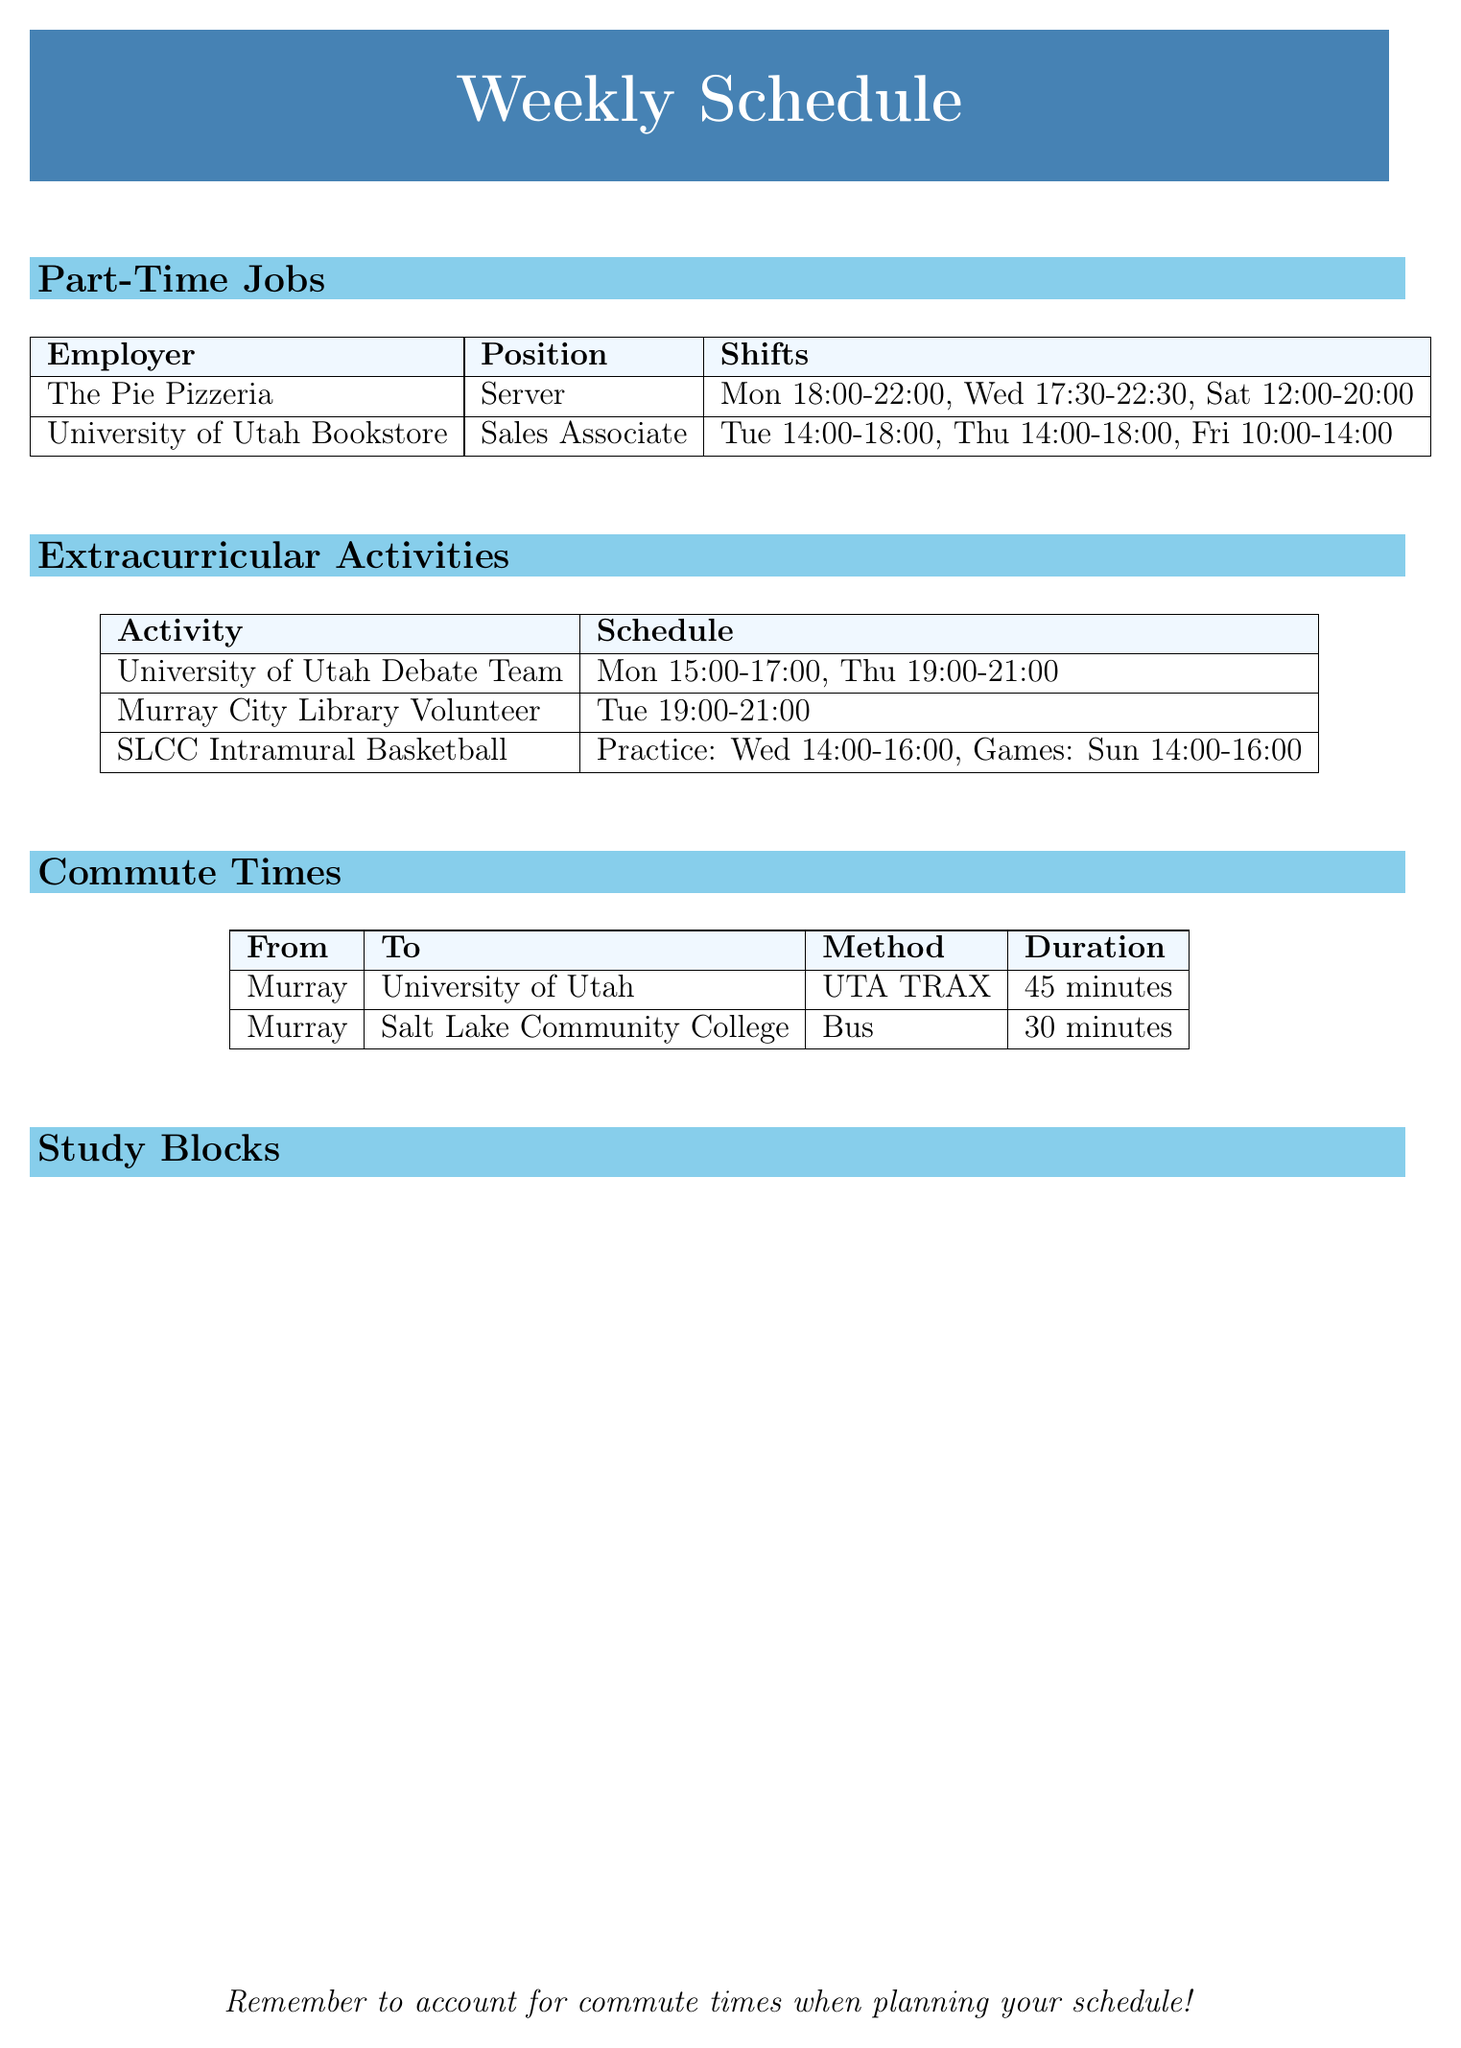What day does the University of Utah Debate Team meet? The University of Utah Debate Team meets on Monday and Thursday, according to the schedule.
Answer: Monday What position do you hold at The Pie Pizzeria? The document states that you work as a Server at The Pie Pizzeria.
Answer: Server How long does it take to commute from Murray to Salt Lake Community College? The document provides the duration of the commute to Salt Lake Community College as 30 minutes.
Answer: 30 minutes What time is the basketball practice on Wednesday? According to the schedule, Salt Lake Community College Intramural Basketball has practice on Wednesday from 14:00 to 16:00.
Answer: 14:00-16:00 Which day do you volunteer at Murray City Library? The schedule indicates that volunteering at Murray City Library is on Tuesday.
Answer: Tuesday How many hours do you work at the University of Utah Bookstore on Friday? The document specifies that the shift on Friday is from 10:00 to 14:00, which totals 4 hours.
Answer: 4 hours What is the latest shift of the week at The Pie Pizzeria? The document shows that the latest shift at The Pie Pizzeria is on Wednesday from 17:30 to 22:30.
Answer: Wednesday 17:30-22:30 Which extracurricular activity has meetings on Monday? The University of Utah Debate Team is scheduled to meet on Monday.
Answer: University of Utah Debate Team How many total study blocks are listed in the document? The document lists seven study blocks for the week.
Answer: 7 